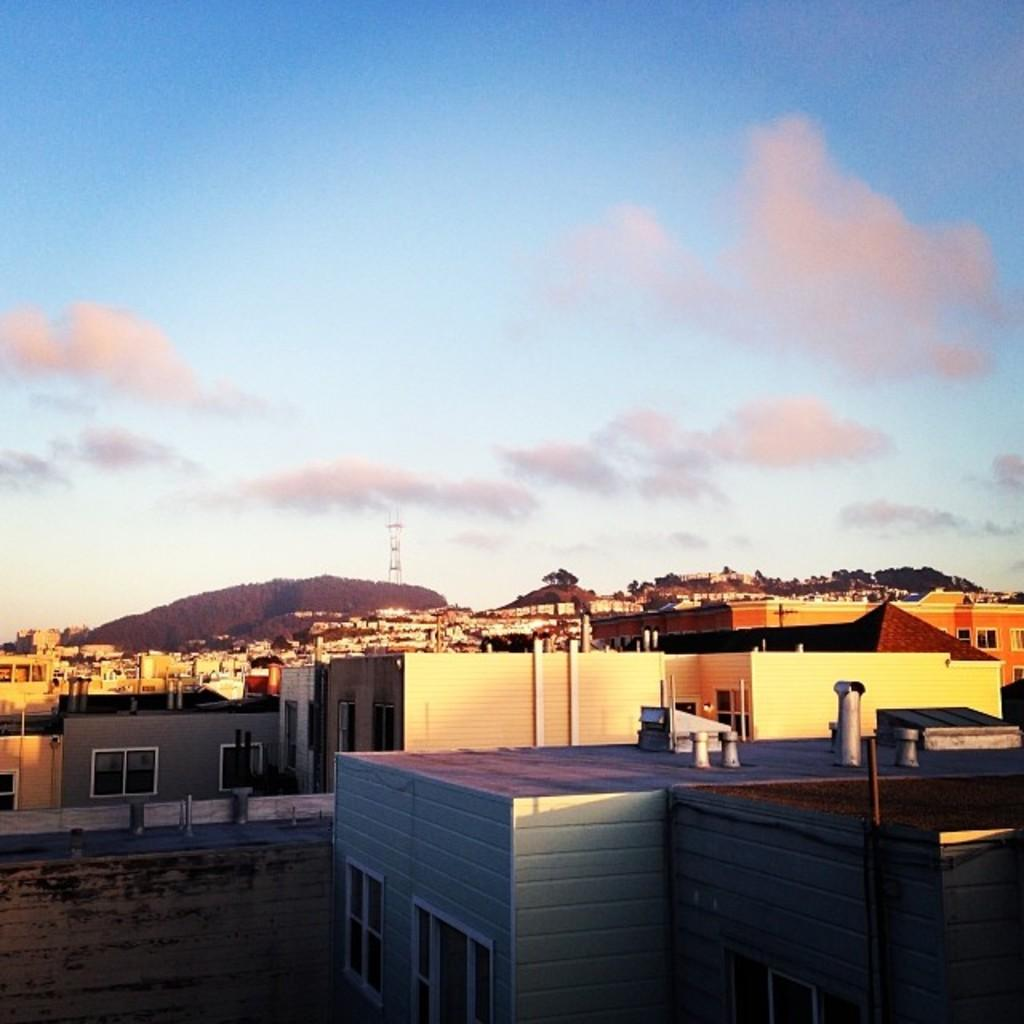What type of structures can be seen in the image? There are buildings in the image. What natural elements are present in the image? There are trees and a mountain in the image. What other man-made structure can be seen in the image? There is a tower in the image. What is the ground condition in the image? There is water on the ground in the image. What is visible in the sky in the image? There are clouds in the sky in the image, and the sky is blue. What type of game is being played on the grass in the image? There is no grass or game present in the image. How many weeks have passed since the event in the image occurred? The image does not depict an event or a specific time, so it is not possible to determine how many weeks have passed. 